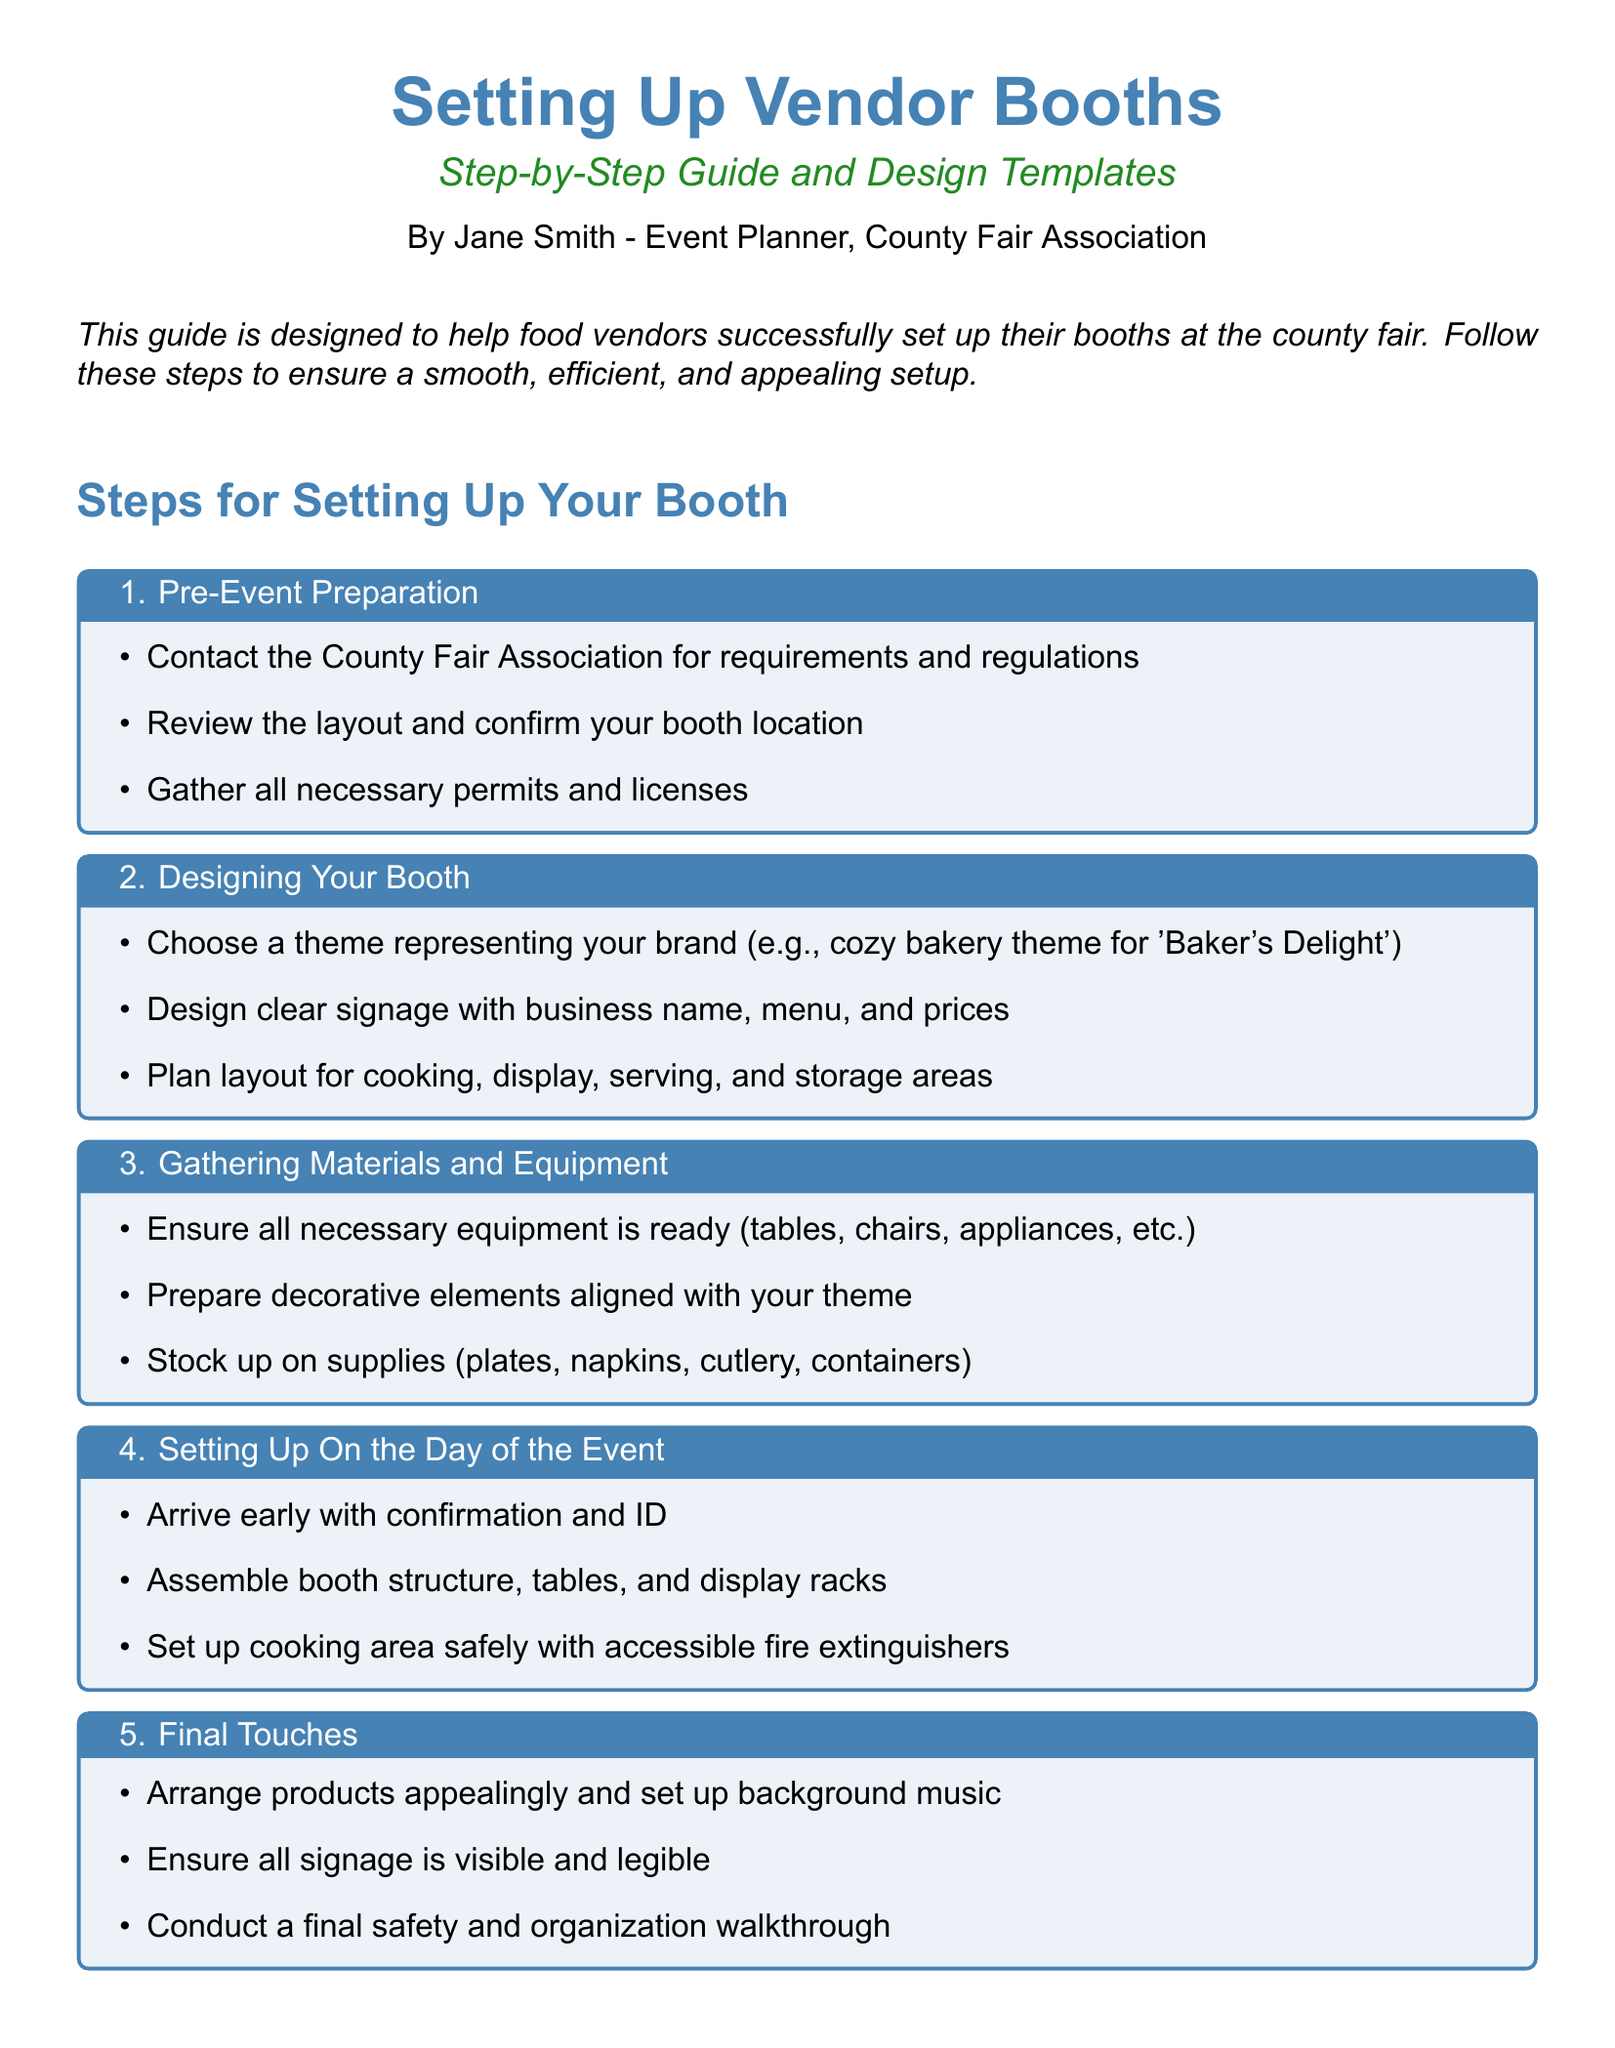What is the title of the document? The title is prominently displayed at the top of the document, stating the main subject of the guide.
Answer: Setting Up Vendor Booths Who is the author of this guide? The author's name is mentioned at the beginning of the document under the title.
Answer: Jane Smith How many steps are outlined for setting up a booth? The number of steps is indicated by the headings before each step.
Answer: 5 What should vendors contact the County Fair Association for? This information is presented in the pre-event preparation section as one of the first tasks.
Answer: Requirements and regulations What type of theme should vendors choose for their booth? This is specified in the design section as part of the preparation for booth setup.
Answer: A theme representing your brand What is the purpose of ensuring safety with fire extinguishers? The document highlights the importance of safety during the booth setup process on the day of the event.
Answer: Safety What is a final task mentioned for setup on the day of the event? This task is included in the final touches section that wraps up the booth preparation.
Answer: Final safety and organization walkthrough 